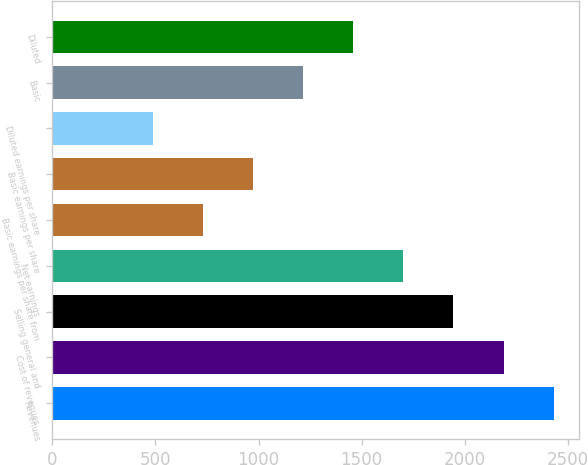Convert chart. <chart><loc_0><loc_0><loc_500><loc_500><bar_chart><fcel>Revenues<fcel>Cost of revenues<fcel>Selling general and<fcel>Net earnings<fcel>Basic earnings per share from<fcel>Basic earnings per share<fcel>Diluted earnings per share<fcel>Basic<fcel>Diluted<nl><fcel>2430.82<fcel>2187.81<fcel>1944.8<fcel>1701.79<fcel>729.75<fcel>972.76<fcel>486.74<fcel>1215.77<fcel>1458.78<nl></chart> 